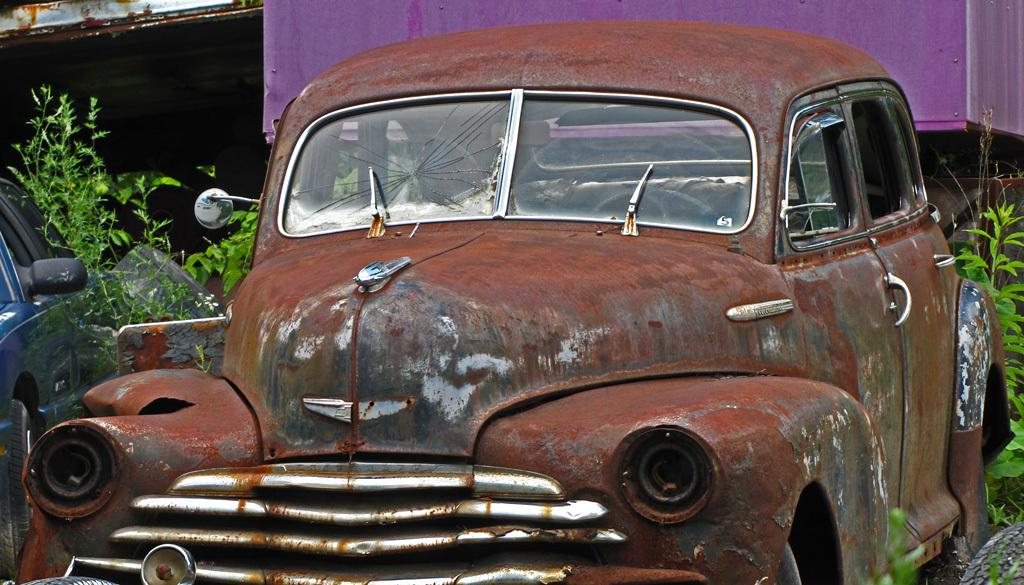What type of vehicles can be seen in the image? There are cars in the image. What other elements are present in the image besides cars? There are plants in the image. Can you describe any objects in the image that have a specific color combination? Yes, there are objects in the image that are pink and black in color. How do the fairies control the cars in the image? There are no fairies present in the image, so they cannot control the cars. 